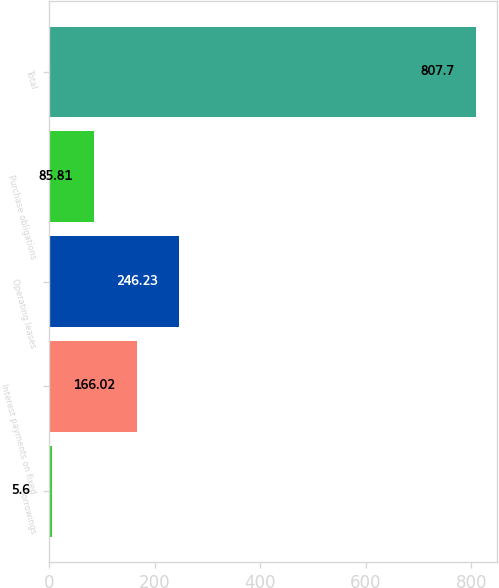Convert chart to OTSL. <chart><loc_0><loc_0><loc_500><loc_500><bar_chart><fcel>Borrowings<fcel>Interest payments on fixed<fcel>Operating leases<fcel>Purchase obligations<fcel>Total<nl><fcel>5.6<fcel>166.02<fcel>246.23<fcel>85.81<fcel>807.7<nl></chart> 